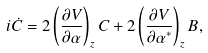<formula> <loc_0><loc_0><loc_500><loc_500>i \dot { C } = 2 \left ( \frac { \partial V } { \partial \alpha } \right ) _ { z } C + 2 \left ( \frac { \partial V } { \partial \alpha ^ { * } } \right ) _ { z } B ,</formula> 